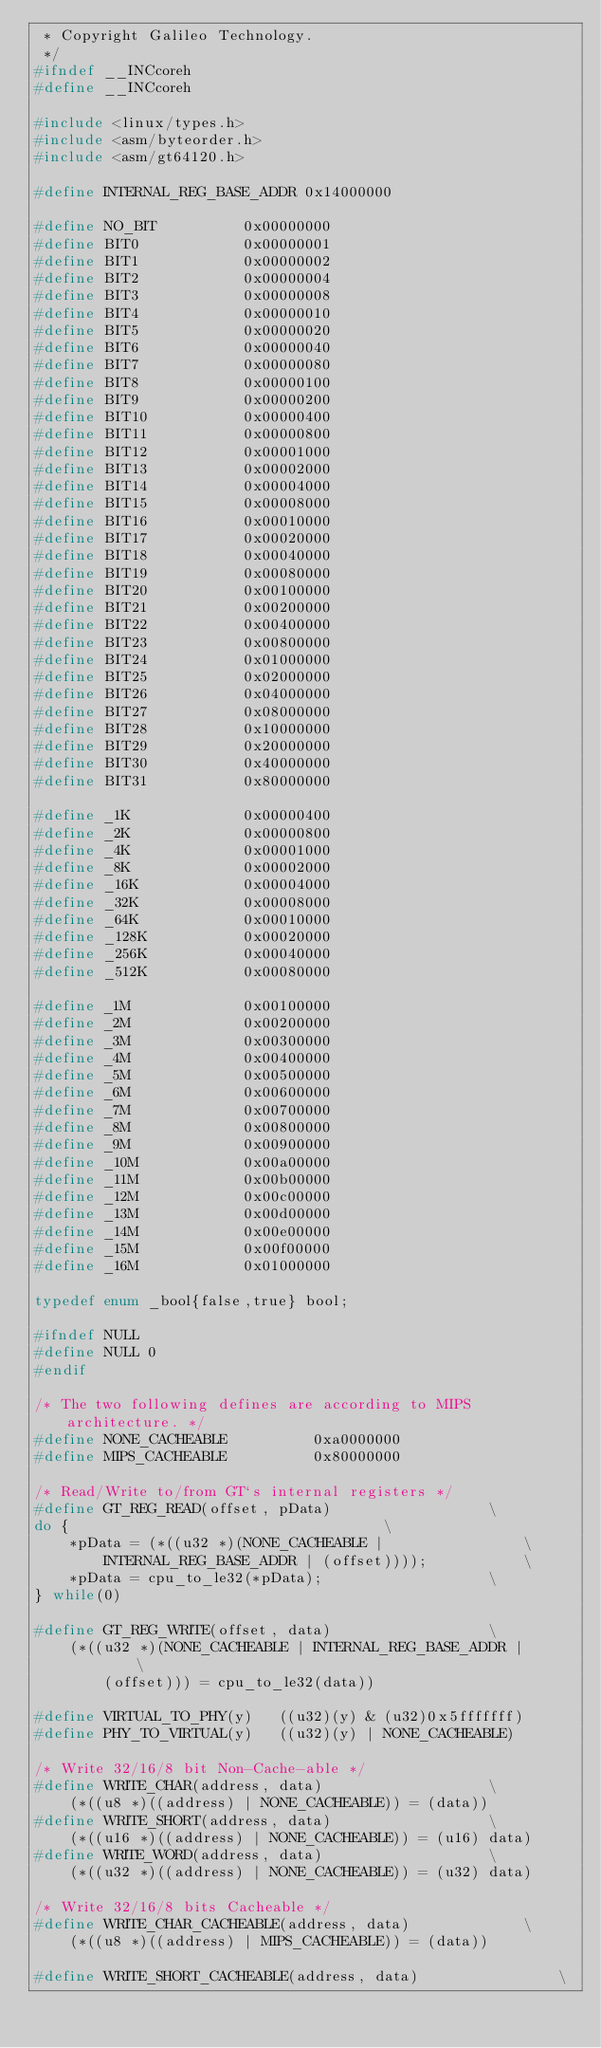<code> <loc_0><loc_0><loc_500><loc_500><_C_> * Copyright Galileo Technology.
 */
#ifndef __INCcoreh
#define __INCcoreh

#include <linux/types.h>
#include <asm/byteorder.h>
#include <asm/gt64120.h>

#define INTERNAL_REG_BASE_ADDR 0x14000000

#define NO_BIT          0x00000000
#define BIT0            0x00000001
#define BIT1            0x00000002
#define BIT2            0x00000004
#define BIT3            0x00000008
#define BIT4            0x00000010
#define BIT5            0x00000020
#define BIT6            0x00000040
#define BIT7            0x00000080
#define BIT8            0x00000100
#define BIT9            0x00000200
#define BIT10           0x00000400
#define BIT11           0x00000800
#define BIT12           0x00001000
#define BIT13           0x00002000
#define BIT14           0x00004000
#define BIT15           0x00008000
#define BIT16           0x00010000
#define BIT17           0x00020000
#define BIT18           0x00040000
#define BIT19           0x00080000
#define BIT20           0x00100000
#define BIT21           0x00200000
#define BIT22           0x00400000
#define BIT23           0x00800000
#define BIT24           0x01000000
#define BIT25           0x02000000
#define BIT26           0x04000000
#define BIT27           0x08000000
#define BIT28           0x10000000
#define BIT29           0x20000000
#define BIT30           0x40000000
#define BIT31           0x80000000

#define _1K             0x00000400
#define _2K             0x00000800
#define _4K             0x00001000
#define _8K             0x00002000
#define _16K            0x00004000
#define _32K            0x00008000
#define _64K            0x00010000
#define _128K           0x00020000
#define _256K           0x00040000
#define _512K           0x00080000

#define _1M             0x00100000
#define _2M             0x00200000
#define _3M             0x00300000
#define _4M             0x00400000
#define _5M             0x00500000
#define _6M             0x00600000
#define _7M             0x00700000
#define _8M             0x00800000
#define _9M             0x00900000
#define _10M            0x00a00000
#define _11M            0x00b00000
#define _12M            0x00c00000
#define _13M            0x00d00000
#define _14M            0x00e00000
#define _15M            0x00f00000
#define _16M            0x01000000

typedef enum _bool{false,true} bool;

#ifndef NULL
#define NULL 0
#endif

/* The two following defines are according to MIPS architecture. */
#define NONE_CACHEABLE			0xa0000000
#define MIPS_CACHEABLE			0x80000000

/* Read/Write to/from GT`s internal registers */
#define GT_REG_READ(offset, pData)					\
do {									\
	*pData = (*((u32 *)(NONE_CACHEABLE |				\
		INTERNAL_REG_BASE_ADDR | (offset))));			\
	*pData = cpu_to_le32(*pData);					\
} while(0)

#define GT_REG_WRITE(offset, data)					\
	(*((u32 *)(NONE_CACHEABLE | INTERNAL_REG_BASE_ADDR |		\
		(offset))) = cpu_to_le32(data))

#define VIRTUAL_TO_PHY(y)	((u32)(y) & (u32)0x5fffffff)
#define PHY_TO_VIRTUAL(y)	((u32)(y) | NONE_CACHEABLE)

/* Write 32/16/8 bit Non-Cache-able */
#define WRITE_CHAR(address, data)					\
	(*((u8 *)((address) | NONE_CACHEABLE)) = (data))
#define WRITE_SHORT(address, data)					\
	(*((u16 *)((address) | NONE_CACHEABLE)) = (u16) data)
#define WRITE_WORD(address, data)					\
	(*((u32 *)((address) | NONE_CACHEABLE)) = (u32) data)

/* Write 32/16/8 bits Cacheable */
#define WRITE_CHAR_CACHEABLE(address, data)				\
	(*((u8 *)((address) | MIPS_CACHEABLE)) = (data))

#define WRITE_SHORT_CACHEABLE(address, data)				\</code> 